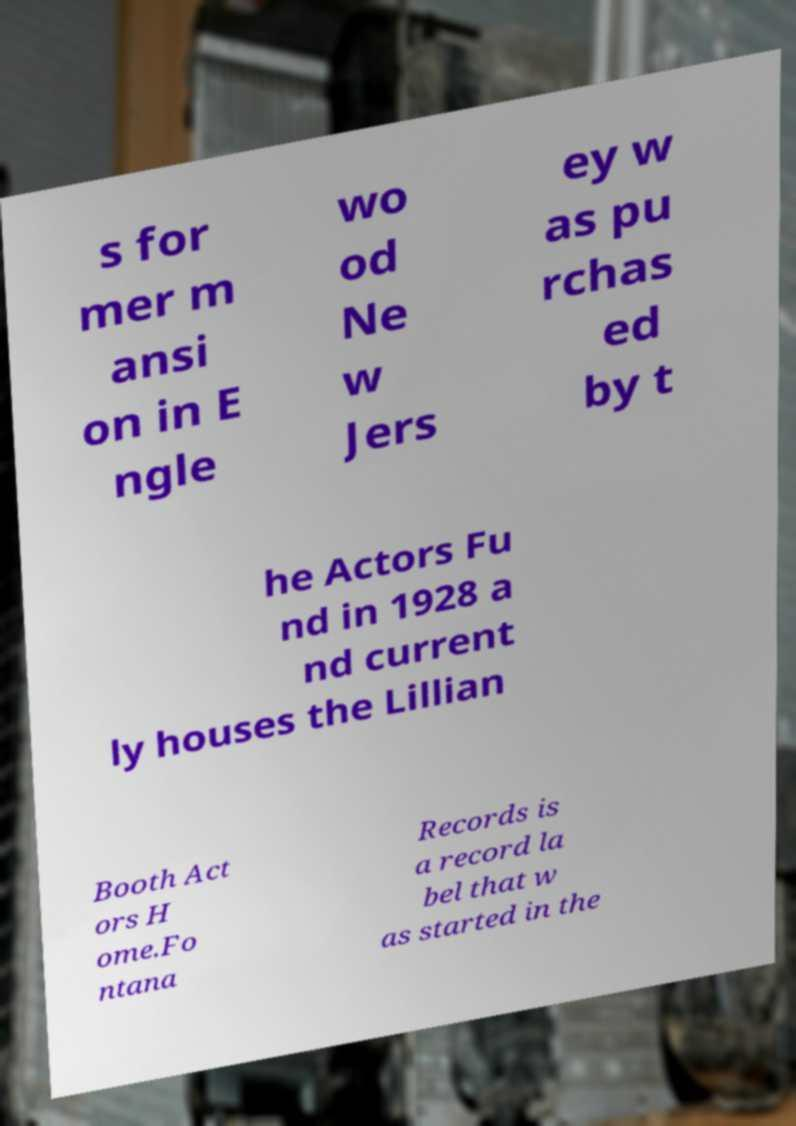Can you accurately transcribe the text from the provided image for me? s for mer m ansi on in E ngle wo od Ne w Jers ey w as pu rchas ed by t he Actors Fu nd in 1928 a nd current ly houses the Lillian Booth Act ors H ome.Fo ntana Records is a record la bel that w as started in the 